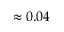Convert formula to latex. <formula><loc_0><loc_0><loc_500><loc_500>\approx 0 . 0 4</formula> 